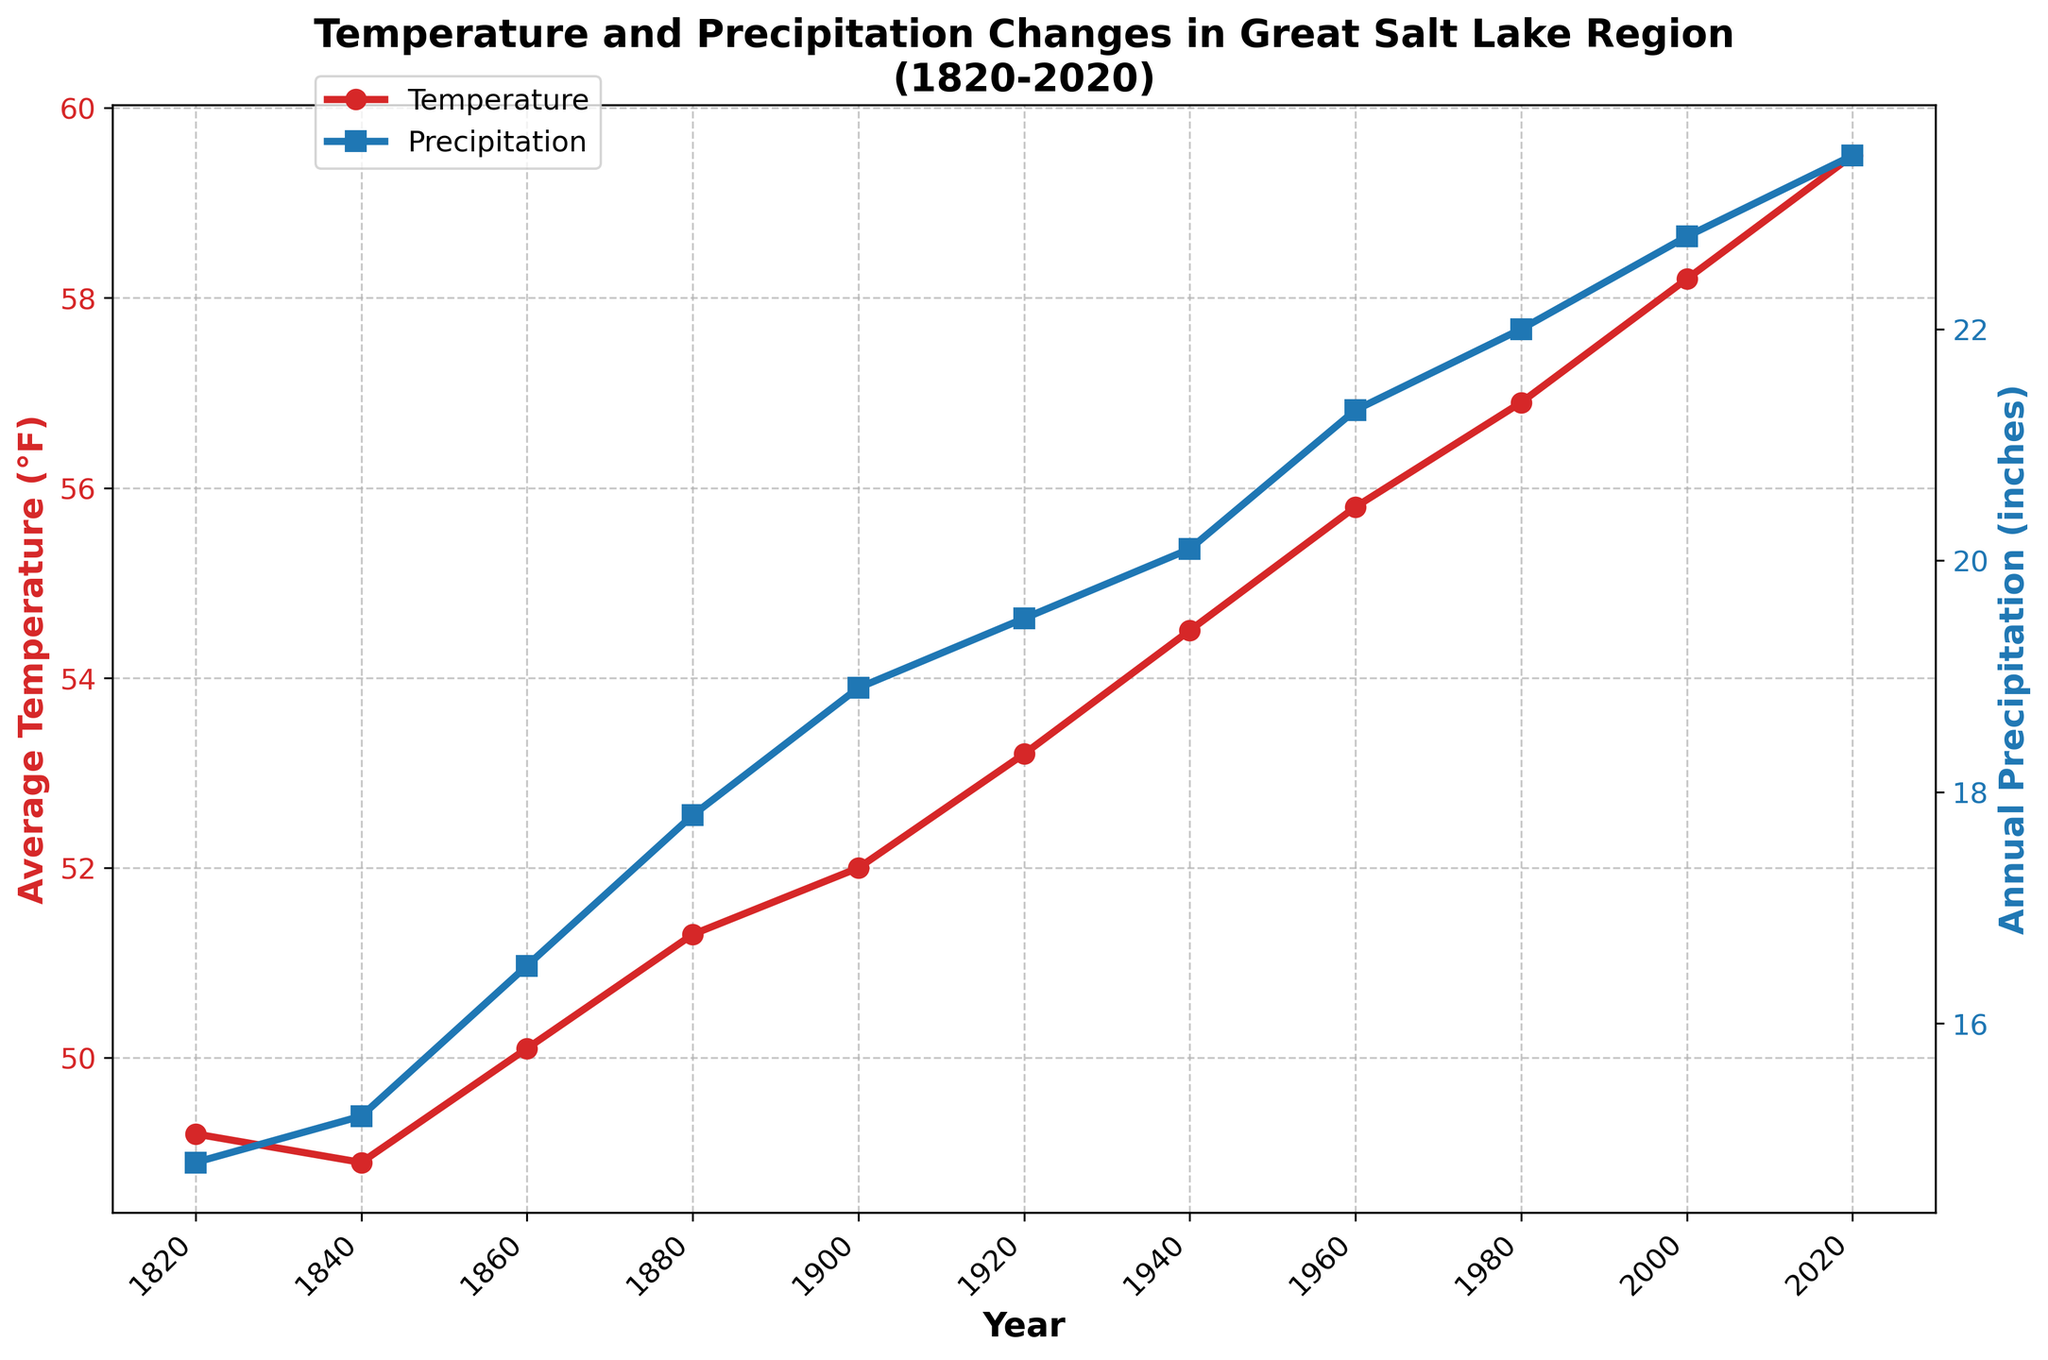What's the overall trend in average temperature from 1820 to 2020? The average temperature shows a general increasing trend from 1820 to 2020, starting around 49.2°F in 1820 and rising to 59.5°F in 2020.
Answer: Increasing How has annual precipitation changed from 1820 to 2020? The annual precipitation has shown an increasing trend from 1820 to 2020, starting at 14.8 inches in 1820 and rising to 23.5 inches in 2020.
Answer: Increasing Which year shows the highest average temperature and what is it? According to the line chart, the year 2020 shows the highest average temperature, which is 59.5°F.
Answer: 2020, 59.5°F Compare the annual precipitation in 1860 and 1960. Which year had more precipitation and by how much? In 1860, the annual precipitation was 16.5 inches, and in 1960, it was 21.3 inches. So, 1960 had more precipitation by 21.3 - 16.5 = 4.8 inches.
Answer: 1960, 4.8 inches Between which consecutive years did the average temperature increase the most? The largest increase in average temperature appears between 2000 (58.2°F) and 2020 (59.5°F), which is an increment of 1.3°F.
Answer: 2000 and 2020 What is the difference in average temperature between 1820 and 1920? The average temperature in 1820 was 49.2°F, and in 1920 it was 53.2°F. The difference is 53.2 - 49.2 = 4°F.
Answer: 4°F Between which consecutive years did the annual precipitation increase the most? The largest increase in annual precipitation appears between 1860 (16.5 inches) and 1880 (17.8 inches), which is an increase of 17.8 - 16.5 = 1.3 inches.
Answer: 1860 and 1880 What are the color representations for temperature and precipitation in the chart? In the chart, temperature is represented by red lines and markers, and precipitation is represented by blue lines and markers.
Answer: Temperature: red, Precipitation: blue Is there any year where both temperature and precipitation increased compared to the previous data point? If so, name one. Yes, between 1960 and 1980, both the average temperature increased from 55.8°F to 56.9°F, and the annual precipitation increased from 21.3 inches to 22 inches.
Answer: 1960 to 1980 What is the average annual precipitation over the entire period from 1820 to 2020? Sum all the annual precipitation values from 1820 to 2020: 14.8 + 15.2 + 16.5 + 17.8 + 18.9 + 19.5 + 20.1 + 21.3 + 22.0 + 22.8 + 23.5 = 212.4 inches. There are 11 data points, so the average is 212.4/11 = 19.31 inches.
Answer: 19.31 inches 